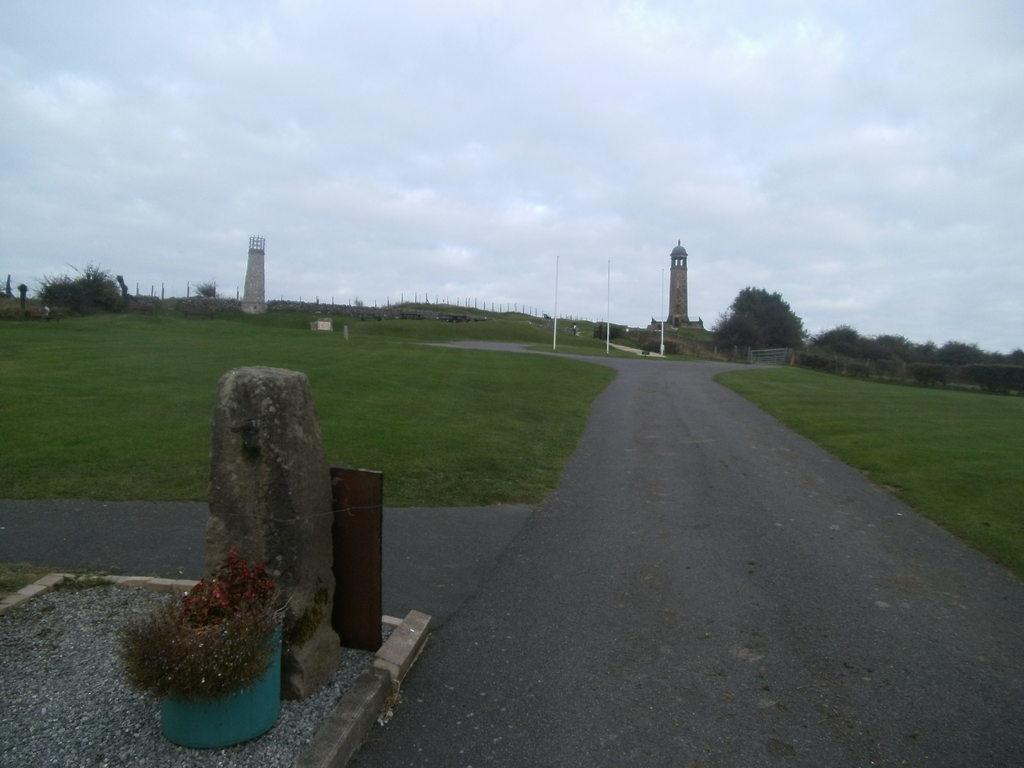Can you describe this image briefly? On the right there are trees and grass. In the center of the picture there are grass, road, poles, fencing and a monument. On the left there are grass, gravel, plant, stone, frame, tower, trees and fencing. Sky is cloudy. 